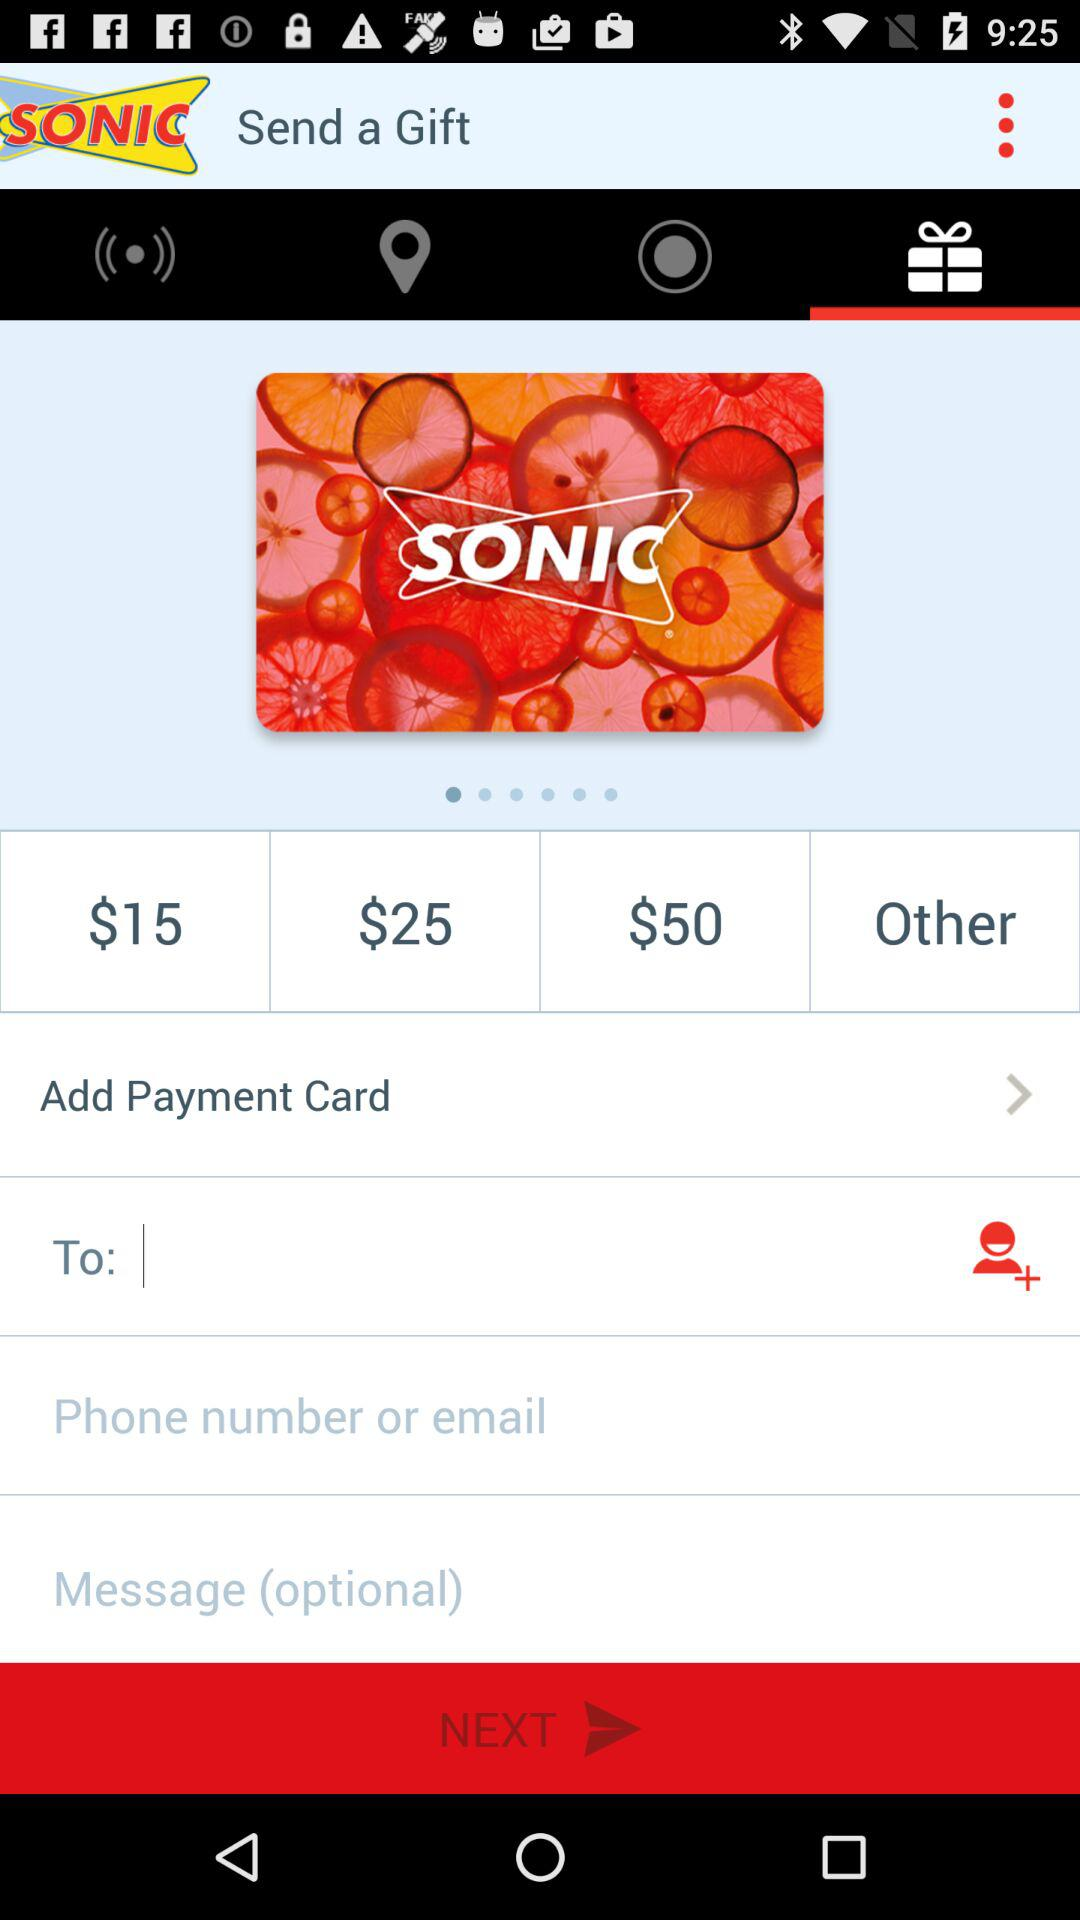What is the currency of the cost? The currency is $. 